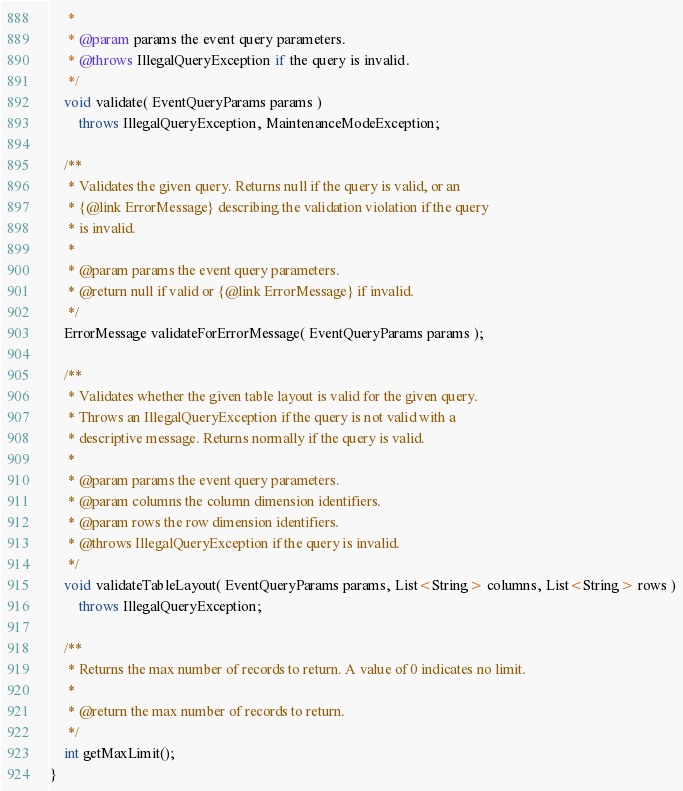Convert code to text. <code><loc_0><loc_0><loc_500><loc_500><_Java_>     *
     * @param params the event query parameters.
     * @throws IllegalQueryException if the query is invalid.
     */
    void validate( EventQueryParams params )
        throws IllegalQueryException, MaintenanceModeException;

    /**
     * Validates the given query. Returns null if the query is valid, or an
     * {@link ErrorMessage} describing the validation violation if the query
     * is invalid.
     *
     * @param params the event query parameters.
     * @return null if valid or {@link ErrorMessage} if invalid.
     */
    ErrorMessage validateForErrorMessage( EventQueryParams params );

    /**
     * Validates whether the given table layout is valid for the given query.
     * Throws an IllegalQueryException if the query is not valid with a
     * descriptive message. Returns normally if the query is valid.
     *
     * @param params the event query parameters.
     * @param columns the column dimension identifiers.
     * @param rows the row dimension identifiers.
     * @throws IllegalQueryException if the query is invalid.
     */
    void validateTableLayout( EventQueryParams params, List<String> columns, List<String> rows )
        throws IllegalQueryException;

    /**
     * Returns the max number of records to return. A value of 0 indicates no limit.
     *
     * @return the max number of records to return.
     */
    int getMaxLimit();
}
</code> 